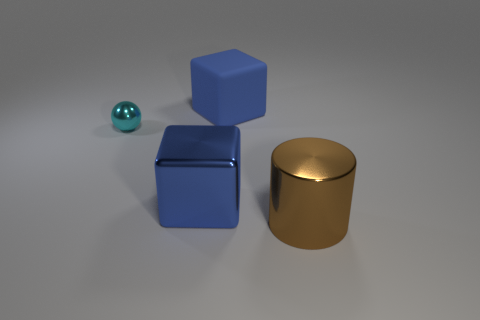Add 1 small cyan spheres. How many objects exist? 5 Subtract all balls. How many objects are left? 3 Subtract all blue metal objects. Subtract all shiny objects. How many objects are left? 0 Add 1 brown things. How many brown things are left? 2 Add 3 tiny metallic balls. How many tiny metallic balls exist? 4 Subtract 0 brown spheres. How many objects are left? 4 